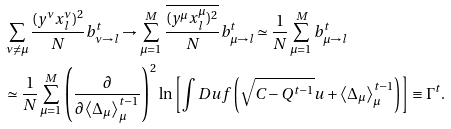<formula> <loc_0><loc_0><loc_500><loc_500>& \sum _ { \nu \ne \mu } \frac { ( y ^ { \nu } x _ { l } ^ { \nu } ) ^ { 2 } } { N } b _ { \nu \to l } ^ { t } \to \sum _ { \mu = 1 } ^ { M } \frac { \overline { ( y ^ { \mu } x _ { l } ^ { \mu } ) ^ { 2 } } } { N } b _ { \mu \to l } ^ { t } \simeq \frac { 1 } { N } \sum _ { \mu = 1 } ^ { M } b _ { \mu \to l } ^ { t } \\ & \simeq \frac { 1 } { N } \sum _ { \mu = 1 } ^ { M } \left ( \frac { \partial } { \partial \left \langle \Delta _ { \mu } \right \rangle _ { \mu } ^ { t - 1 } } \right ) ^ { 2 } \ln \left [ \int D u f \left ( \sqrt { C - Q ^ { t - 1 } } u + \left \langle \Delta _ { \mu } \right \rangle _ { \mu } ^ { t - 1 } \right ) \right ] \equiv \Gamma ^ { t } .</formula> 